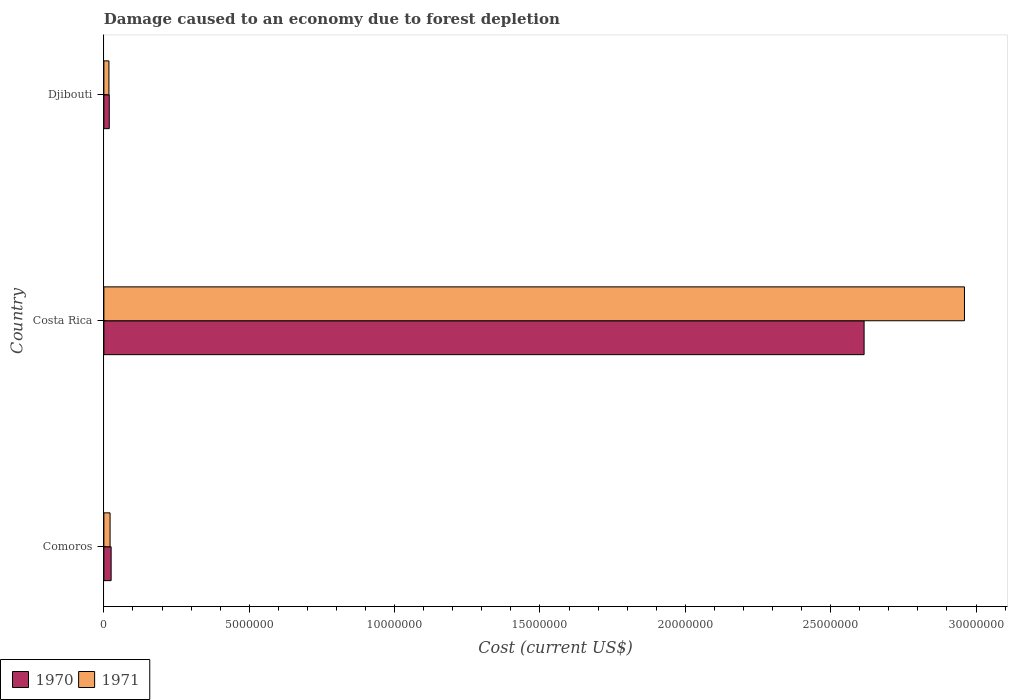Are the number of bars per tick equal to the number of legend labels?
Provide a short and direct response. Yes. Are the number of bars on each tick of the Y-axis equal?
Your answer should be very brief. Yes. How many bars are there on the 2nd tick from the bottom?
Provide a succinct answer. 2. What is the label of the 2nd group of bars from the top?
Keep it short and to the point. Costa Rica. What is the cost of damage caused due to forest depletion in 1970 in Comoros?
Your response must be concise. 2.49e+05. Across all countries, what is the maximum cost of damage caused due to forest depletion in 1970?
Offer a very short reply. 2.61e+07. Across all countries, what is the minimum cost of damage caused due to forest depletion in 1970?
Make the answer very short. 1.85e+05. In which country was the cost of damage caused due to forest depletion in 1971 minimum?
Your answer should be very brief. Djibouti. What is the total cost of damage caused due to forest depletion in 1970 in the graph?
Your answer should be compact. 2.66e+07. What is the difference between the cost of damage caused due to forest depletion in 1970 in Comoros and that in Costa Rica?
Offer a terse response. -2.59e+07. What is the difference between the cost of damage caused due to forest depletion in 1970 in Costa Rica and the cost of damage caused due to forest depletion in 1971 in Comoros?
Your answer should be very brief. 2.59e+07. What is the average cost of damage caused due to forest depletion in 1970 per country?
Make the answer very short. 8.86e+06. What is the difference between the cost of damage caused due to forest depletion in 1970 and cost of damage caused due to forest depletion in 1971 in Comoros?
Make the answer very short. 3.63e+04. What is the ratio of the cost of damage caused due to forest depletion in 1970 in Comoros to that in Djibouti?
Ensure brevity in your answer.  1.35. Is the cost of damage caused due to forest depletion in 1971 in Costa Rica less than that in Djibouti?
Make the answer very short. No. What is the difference between the highest and the second highest cost of damage caused due to forest depletion in 1970?
Offer a very short reply. 2.59e+07. What is the difference between the highest and the lowest cost of damage caused due to forest depletion in 1970?
Offer a terse response. 2.60e+07. In how many countries, is the cost of damage caused due to forest depletion in 1971 greater than the average cost of damage caused due to forest depletion in 1971 taken over all countries?
Your response must be concise. 1. Is the sum of the cost of damage caused due to forest depletion in 1970 in Comoros and Costa Rica greater than the maximum cost of damage caused due to forest depletion in 1971 across all countries?
Your response must be concise. No. How many countries are there in the graph?
Keep it short and to the point. 3. What is the difference between two consecutive major ticks on the X-axis?
Give a very brief answer. 5.00e+06. Are the values on the major ticks of X-axis written in scientific E-notation?
Ensure brevity in your answer.  No. Does the graph contain any zero values?
Offer a very short reply. No. How many legend labels are there?
Give a very brief answer. 2. What is the title of the graph?
Your response must be concise. Damage caused to an economy due to forest depletion. Does "1995" appear as one of the legend labels in the graph?
Ensure brevity in your answer.  No. What is the label or title of the X-axis?
Provide a short and direct response. Cost (current US$). What is the label or title of the Y-axis?
Offer a terse response. Country. What is the Cost (current US$) in 1970 in Comoros?
Give a very brief answer. 2.49e+05. What is the Cost (current US$) of 1971 in Comoros?
Make the answer very short. 2.13e+05. What is the Cost (current US$) in 1970 in Costa Rica?
Keep it short and to the point. 2.61e+07. What is the Cost (current US$) in 1971 in Costa Rica?
Ensure brevity in your answer.  2.96e+07. What is the Cost (current US$) of 1970 in Djibouti?
Offer a terse response. 1.85e+05. What is the Cost (current US$) of 1971 in Djibouti?
Provide a succinct answer. 1.73e+05. Across all countries, what is the maximum Cost (current US$) in 1970?
Give a very brief answer. 2.61e+07. Across all countries, what is the maximum Cost (current US$) in 1971?
Offer a terse response. 2.96e+07. Across all countries, what is the minimum Cost (current US$) of 1970?
Your answer should be very brief. 1.85e+05. Across all countries, what is the minimum Cost (current US$) in 1971?
Provide a succinct answer. 1.73e+05. What is the total Cost (current US$) in 1970 in the graph?
Your answer should be very brief. 2.66e+07. What is the total Cost (current US$) in 1971 in the graph?
Offer a very short reply. 3.00e+07. What is the difference between the Cost (current US$) of 1970 in Comoros and that in Costa Rica?
Ensure brevity in your answer.  -2.59e+07. What is the difference between the Cost (current US$) in 1971 in Comoros and that in Costa Rica?
Make the answer very short. -2.94e+07. What is the difference between the Cost (current US$) in 1970 in Comoros and that in Djibouti?
Your answer should be very brief. 6.42e+04. What is the difference between the Cost (current US$) in 1971 in Comoros and that in Djibouti?
Give a very brief answer. 3.93e+04. What is the difference between the Cost (current US$) in 1970 in Costa Rica and that in Djibouti?
Provide a succinct answer. 2.60e+07. What is the difference between the Cost (current US$) of 1971 in Costa Rica and that in Djibouti?
Your answer should be compact. 2.94e+07. What is the difference between the Cost (current US$) in 1970 in Comoros and the Cost (current US$) in 1971 in Costa Rica?
Provide a short and direct response. -2.94e+07. What is the difference between the Cost (current US$) in 1970 in Comoros and the Cost (current US$) in 1971 in Djibouti?
Give a very brief answer. 7.56e+04. What is the difference between the Cost (current US$) in 1970 in Costa Rica and the Cost (current US$) in 1971 in Djibouti?
Offer a terse response. 2.60e+07. What is the average Cost (current US$) in 1970 per country?
Your answer should be very brief. 8.86e+06. What is the average Cost (current US$) of 1971 per country?
Provide a succinct answer. 1.00e+07. What is the difference between the Cost (current US$) of 1970 and Cost (current US$) of 1971 in Comoros?
Offer a terse response. 3.63e+04. What is the difference between the Cost (current US$) of 1970 and Cost (current US$) of 1971 in Costa Rica?
Provide a succinct answer. -3.45e+06. What is the difference between the Cost (current US$) in 1970 and Cost (current US$) in 1971 in Djibouti?
Keep it short and to the point. 1.14e+04. What is the ratio of the Cost (current US$) in 1970 in Comoros to that in Costa Rica?
Provide a short and direct response. 0.01. What is the ratio of the Cost (current US$) of 1971 in Comoros to that in Costa Rica?
Provide a succinct answer. 0.01. What is the ratio of the Cost (current US$) in 1970 in Comoros to that in Djibouti?
Offer a very short reply. 1.35. What is the ratio of the Cost (current US$) of 1971 in Comoros to that in Djibouti?
Ensure brevity in your answer.  1.23. What is the ratio of the Cost (current US$) of 1970 in Costa Rica to that in Djibouti?
Give a very brief answer. 141.54. What is the ratio of the Cost (current US$) in 1971 in Costa Rica to that in Djibouti?
Ensure brevity in your answer.  170.8. What is the difference between the highest and the second highest Cost (current US$) of 1970?
Your response must be concise. 2.59e+07. What is the difference between the highest and the second highest Cost (current US$) of 1971?
Ensure brevity in your answer.  2.94e+07. What is the difference between the highest and the lowest Cost (current US$) in 1970?
Ensure brevity in your answer.  2.60e+07. What is the difference between the highest and the lowest Cost (current US$) of 1971?
Provide a succinct answer. 2.94e+07. 